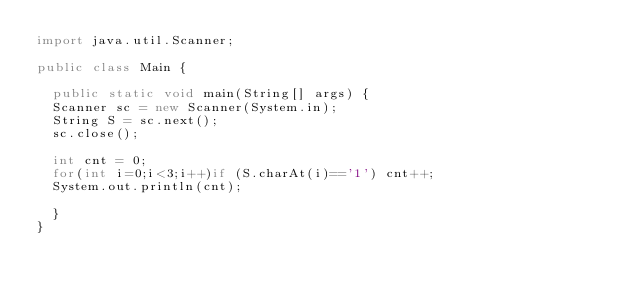<code> <loc_0><loc_0><loc_500><loc_500><_Java_>import java.util.Scanner;

public class Main {

	public static void main(String[] args) {
	Scanner sc = new Scanner(System.in);
	String S = sc.next();
	sc.close();
	
	int cnt = 0;
	for(int i=0;i<3;i++)if (S.charAt(i)=='1') cnt++;
	System.out.println(cnt);
	
	}
}
</code> 